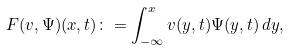<formula> <loc_0><loc_0><loc_500><loc_500>F ( v , \Psi ) ( x , t ) \colon = \int _ { - \infty } ^ { x } v ( y , t ) \Psi ( y , t ) \, d y ,</formula> 